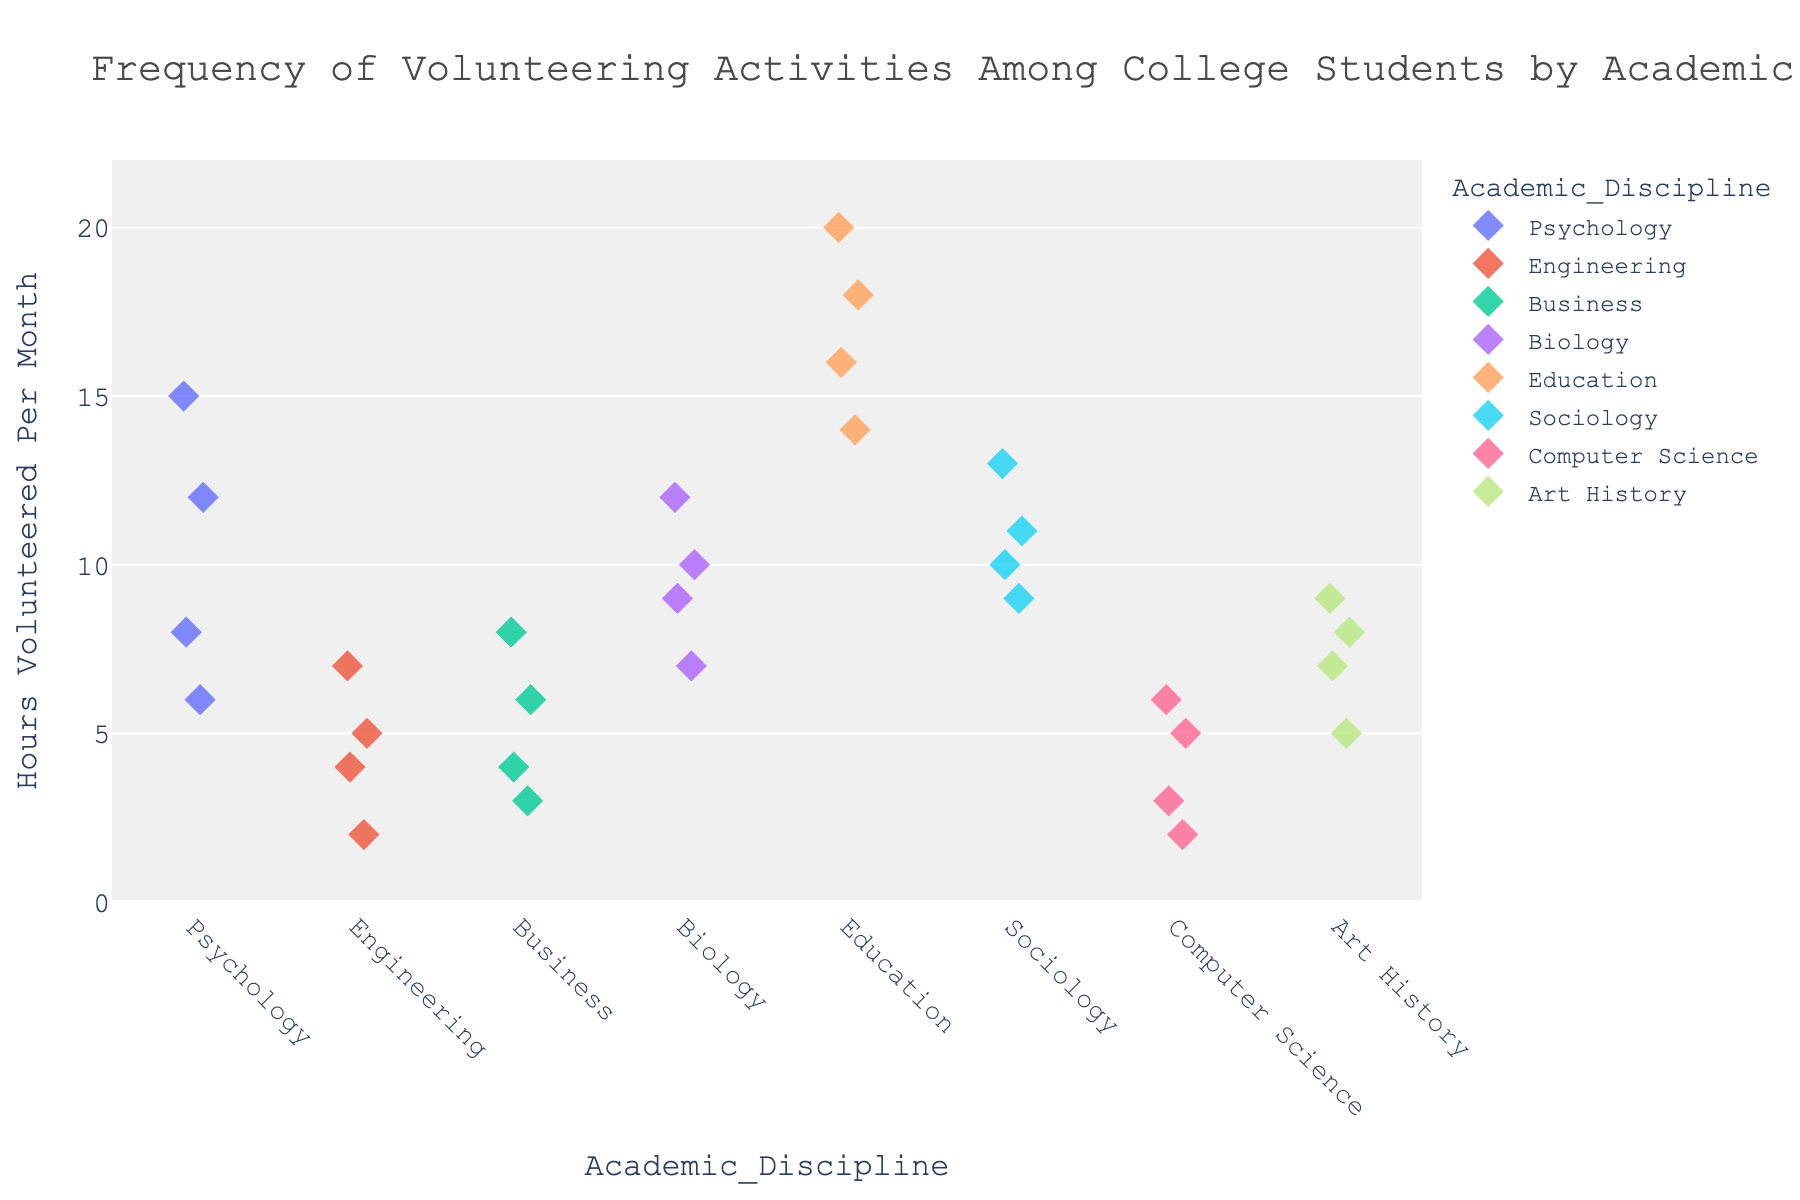What is the title of the figure? The title is typically found at the top of the figure. Here, it reads: "Frequency of Volunteering Activities Among College Students by Academic Discipline."
Answer: Frequency of Volunteering Activities Among College Students by Academic Discipline What is the range of hours volunteered per month across all disciplines? The y-axis shows "Hours Volunteered Per Month" and the range is given from 0 to the maximum value recorded in the dataset. The y-axis range is 0 to a bit above 20, approximately 22 since we adjusted it to 1.1 times the maximum value (20).
Answer: 0 to ~22 Which academic discipline has the highest individual volunteering hours? By looking at the highest point on the y-axis, it corresponds to Education, which has the highest value of 20 hours.
Answer: Education How many data points are there in the Psychology discipline? Count the number of markers (diamonds) along the x-axis label "Psychology." There are 4 data points.
Answer: 4 Which discipline has the broadest range of hours volunteered per month? Compare the spread of data points along the y-axis for each discipline. Education has the broadest range, from 14 to 20 hours.
Answer: Education What is the median volunteering hours for Sociology? The median is the middle value when data points are ordered. Sociology has four values (9, 10, 11, 13). The median is the average of the two middle numbers: (10 + 11) / 2 = 10.5.
Answer: 10.5 Which disciplines have the same number of highest volunteering hours? Compare the highest points in each group. Education (20 hours) has the highest number followed by Psychology (15 hours), and Sociology (13 hours), with only Education having the highest unique value.
Answer: Only Education What is the average number of volunteered hours per month for Computer Science students? Find the sum of all data points in Computer Science (3, 5, 2, 6) and divide by the number of data points: (3 + 5 + 2 + 6) / 4 = 4.
Answer: 4 Among Engineering, Business, and Psychology, which discipline has the highest maximum volunteering hours? Compare the highest values in each discipline. Engineering has a maximum of (7), Business (8), Psychology (15).
Answer: Psychology Is the distribution of volunteer hours more concentrated in Business or Art History? Compare the spread of the data points along the y-axis for each group. Business's values (3, 6, 4, 8) are more concentrated than Art History's (7, 5, 9, 8).
Answer: Business 